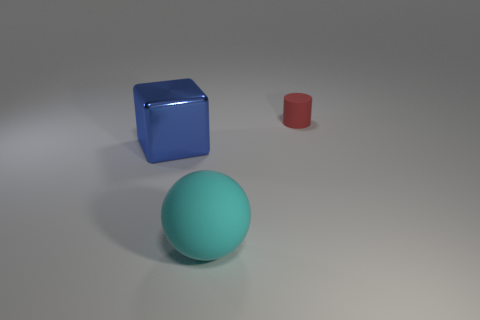Are there more small green metal blocks than large cubes?
Provide a short and direct response. No. There is a matte thing to the left of the small cylinder right of the cyan rubber thing in front of the big blue block; how big is it?
Provide a short and direct response. Large. Is the size of the cylinder the same as the matte thing that is in front of the tiny matte object?
Make the answer very short. No. Is the number of large blocks that are on the right side of the large cyan object less than the number of large purple cylinders?
Offer a terse response. No. How many objects have the same color as the metal block?
Your answer should be very brief. 0. Is the number of matte cylinders less than the number of yellow shiny cylinders?
Your answer should be very brief. No. Is the material of the cube the same as the large cyan sphere?
Offer a terse response. No. What number of other things are the same size as the red object?
Provide a succinct answer. 0. What is the color of the matte object behind the thing left of the cyan rubber thing?
Your answer should be compact. Red. What number of other things are there of the same shape as the tiny red thing?
Offer a very short reply. 0. 